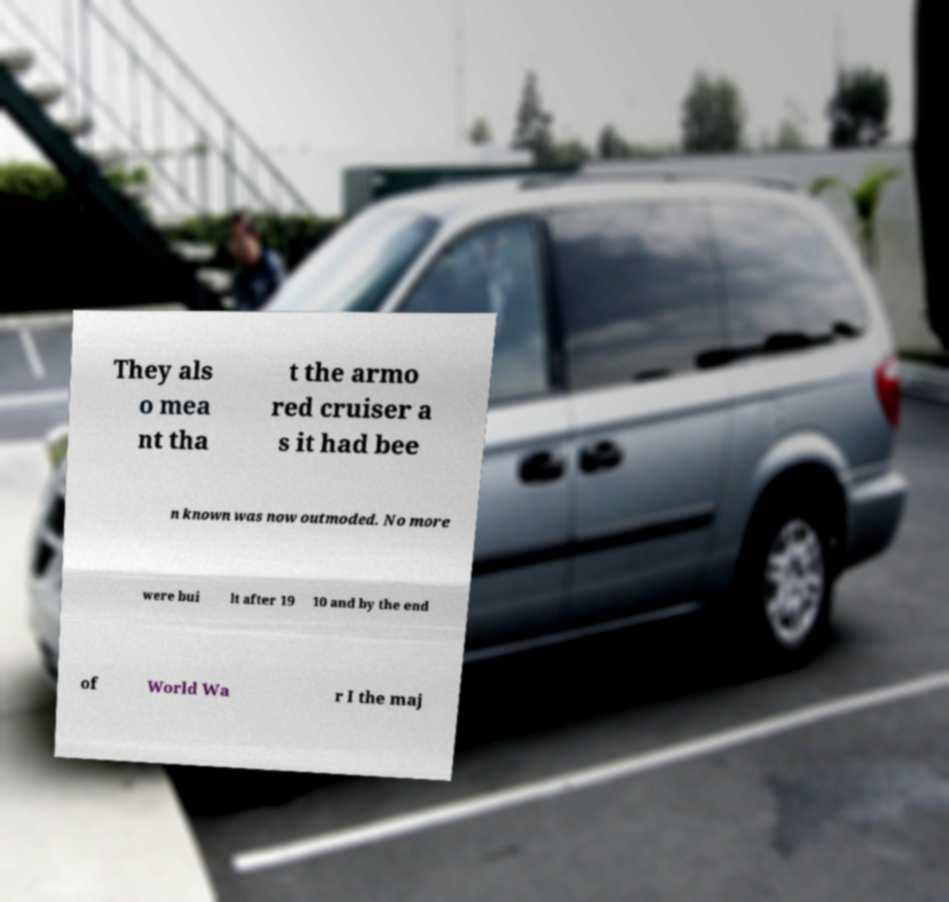I need the written content from this picture converted into text. Can you do that? They als o mea nt tha t the armo red cruiser a s it had bee n known was now outmoded. No more were bui lt after 19 10 and by the end of World Wa r I the maj 